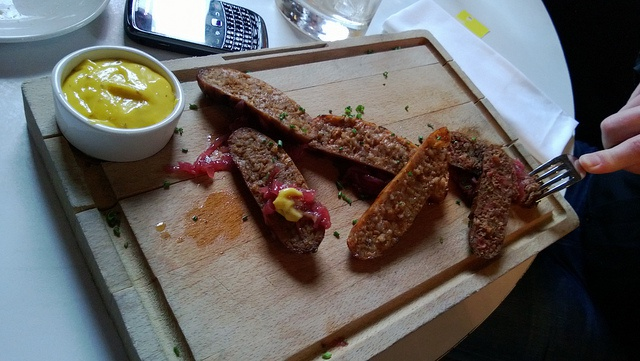Describe the objects in this image and their specific colors. I can see dining table in darkgray, lightblue, black, gray, and maroon tones, bowl in lightblue, olive, gray, and lightgray tones, hot dog in lightblue, black, maroon, and gray tones, cell phone in lightblue, white, black, navy, and gray tones, and hot dog in lightblue, gray, black, and maroon tones in this image. 